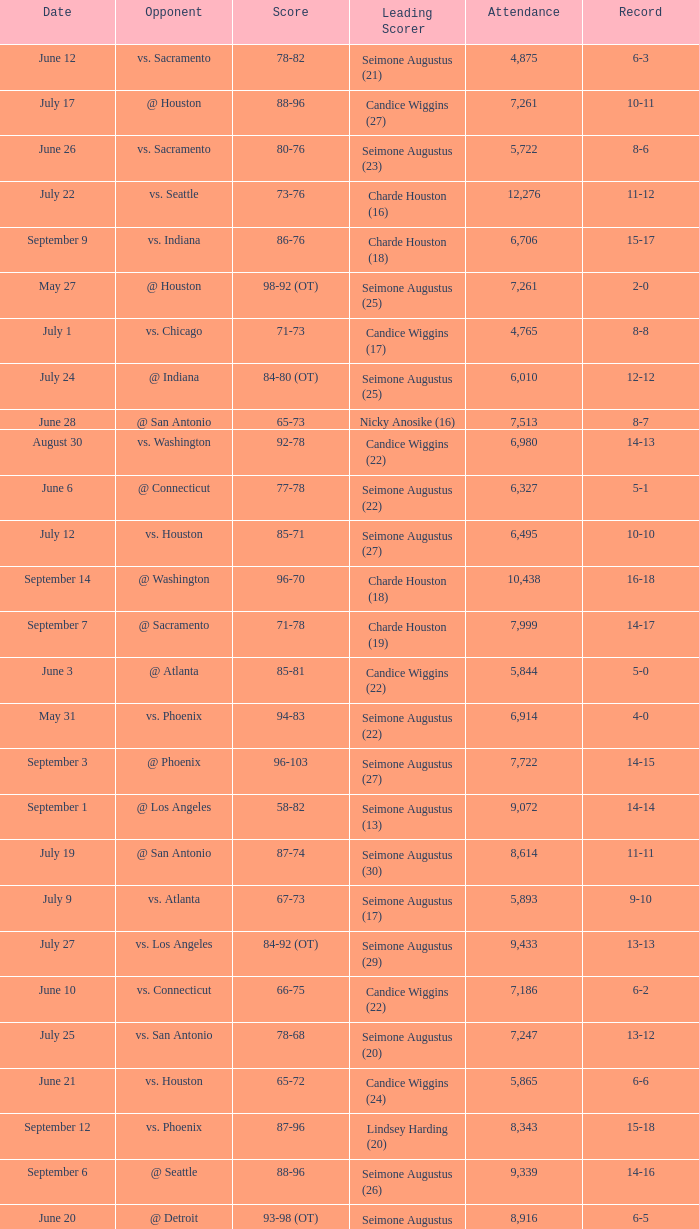Which Score has an Opponent of @ houston, and a Record of 2-0? 98-92 (OT). 